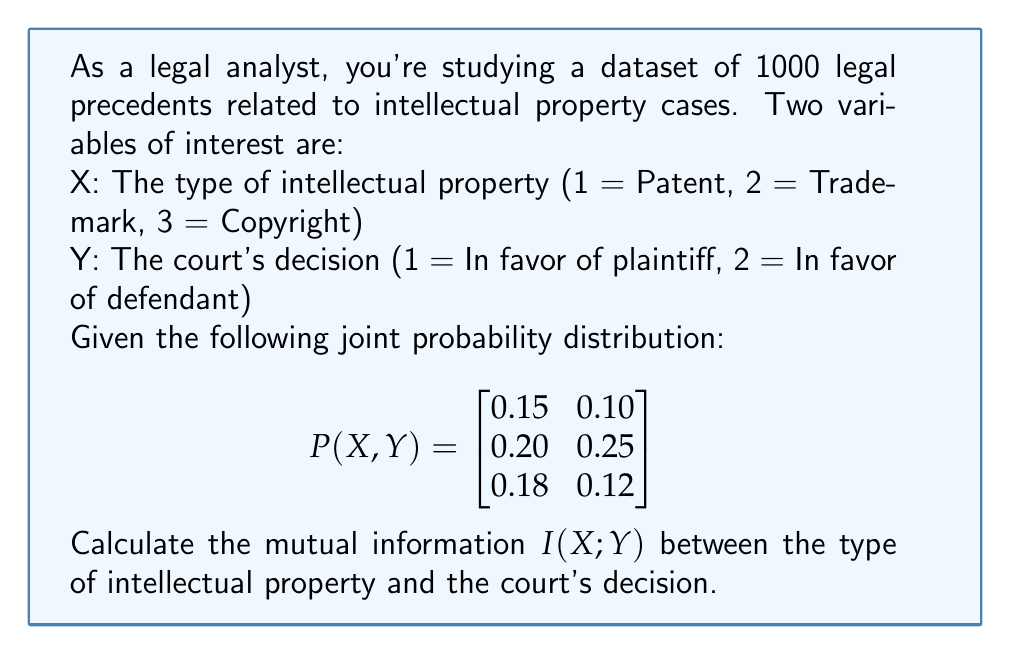Can you answer this question? To calculate the mutual information $I(X;Y)$, we'll follow these steps:

1) First, we need to calculate the marginal probabilities $P(X)$ and $P(Y)$:

   $P(X=1) = 0.15 + 0.10 = 0.25$
   $P(X=2) = 0.20 + 0.25 = 0.45$
   $P(X=3) = 0.18 + 0.12 = 0.30$

   $P(Y=1) = 0.15 + 0.20 + 0.18 = 0.53$
   $P(Y=2) = 0.10 + 0.25 + 0.12 = 0.47$

2) The formula for mutual information is:

   $$I(X;Y) = \sum_{x}\sum_{y} P(x,y) \log_2 \frac{P(x,y)}{P(x)P(y)}$$

3) Let's calculate each term:

   For $X=1, Y=1$: $0.15 \log_2 \frac{0.15}{0.25 \cdot 0.53} = 0.0358$
   For $X=1, Y=2$: $0.10 \log_2 \frac{0.10}{0.25 \cdot 0.47} = 0.0286$
   For $X=2, Y=1$: $0.20 \log_2 \frac{0.20}{0.45 \cdot 0.53} = 0.0099$
   For $X=2, Y=2$: $0.25 \log_2 \frac{0.25}{0.45 \cdot 0.47} = 0.0551$
   For $X=3, Y=1$: $0.18 \log_2 \frac{0.18}{0.30 \cdot 0.53} = 0.0305$
   For $X=3, Y=2$: $0.12 \log_2 \frac{0.12}{0.30 \cdot 0.47} = 0.0136$

4) Sum all these terms:

   $I(X;Y) = 0.0358 + 0.0286 + 0.0099 + 0.0551 + 0.0305 + 0.0136 = 0.1735$

Therefore, the mutual information $I(X;Y)$ is approximately 0.1735 bits.
Answer: $I(X;Y) \approx 0.1735$ bits 